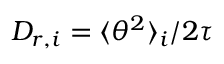Convert formula to latex. <formula><loc_0><loc_0><loc_500><loc_500>D _ { r , i } = \langle \theta ^ { 2 } \rangle _ { i } / 2 \tau</formula> 